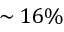<formula> <loc_0><loc_0><loc_500><loc_500>\sim 1 6 \%</formula> 